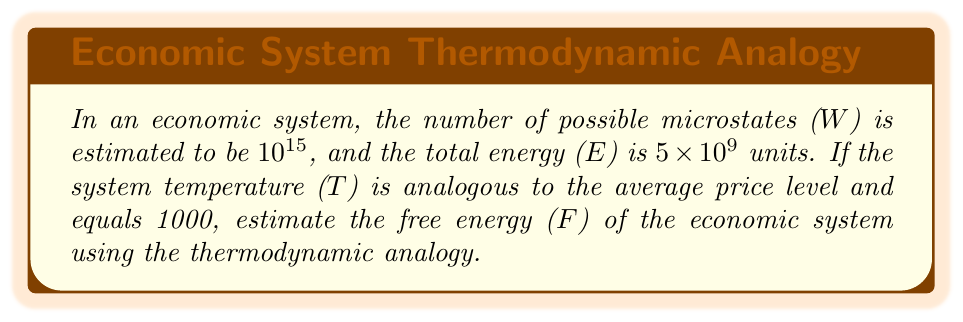Show me your answer to this math problem. To estimate the free energy of the economic system using thermodynamic analogies, we'll follow these steps:

1. Recall the formula for free energy in thermodynamics:
   $$F = E - TS$$

   Where:
   F = Free energy
   E = Total energy
   T = Temperature (analogous to average price level)
   S = Entropy

2. We need to calculate the entropy (S) using Boltzmann's entropy formula:
   $$S = k_B \ln W$$

   Where:
   $k_B$ = Boltzmann constant (we'll use 1 for simplicity in this economic analogy)
   W = Number of microstates

3. Calculate entropy:
   $$S = \ln(10^{15}) = 15 \ln(10) \approx 34.54$$

4. Now we have all the components to calculate free energy:
   E = $5 \times 10^9$ units
   T = 1000
   S ≈ 34.54

5. Substitute these values into the free energy formula:
   $$F = E - TS$$
   $$F = 5 \times 10^9 - 1000 \times 34.54$$
   $$F = 5 \times 10^9 - 34,540$$
   $$F = 4,999,965,460$$

Thus, the estimated free energy of the economic system is approximately 4,999,965,460 units.
Answer: 4,999,965,460 units 